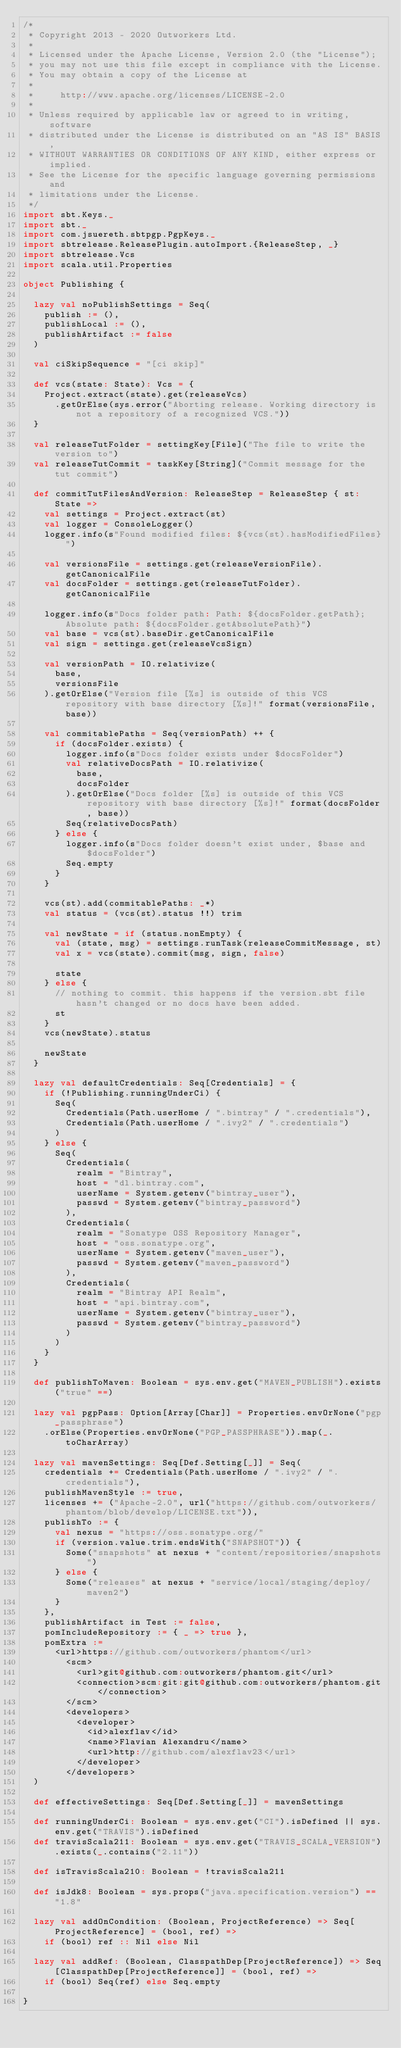<code> <loc_0><loc_0><loc_500><loc_500><_Scala_>/*
 * Copyright 2013 - 2020 Outworkers Ltd.
 *
 * Licensed under the Apache License, Version 2.0 (the "License");
 * you may not use this file except in compliance with the License.
 * You may obtain a copy of the License at
 *
 *     http://www.apache.org/licenses/LICENSE-2.0
 *
 * Unless required by applicable law or agreed to in writing, software
 * distributed under the License is distributed on an "AS IS" BASIS,
 * WITHOUT WARRANTIES OR CONDITIONS OF ANY KIND, either express or implied.
 * See the License for the specific language governing permissions and
 * limitations under the License.
 */
import sbt.Keys._
import sbt._
import com.jsuereth.sbtpgp.PgpKeys._
import sbtrelease.ReleasePlugin.autoImport.{ReleaseStep, _}
import sbtrelease.Vcs
import scala.util.Properties

object Publishing {

  lazy val noPublishSettings = Seq(
    publish := (),
    publishLocal := (),
    publishArtifact := false
  )

  val ciSkipSequence = "[ci skip]"

  def vcs(state: State): Vcs = {
    Project.extract(state).get(releaseVcs)
      .getOrElse(sys.error("Aborting release. Working directory is not a repository of a recognized VCS."))
  }

  val releaseTutFolder = settingKey[File]("The file to write the version to")
  val releaseTutCommit = taskKey[String]("Commit message for the tut commit")

  def commitTutFilesAndVersion: ReleaseStep = ReleaseStep { st: State =>
    val settings = Project.extract(st)
    val logger = ConsoleLogger()
    logger.info(s"Found modified files: ${vcs(st).hasModifiedFiles}")

    val versionsFile = settings.get(releaseVersionFile).getCanonicalFile
    val docsFolder = settings.get(releaseTutFolder).getCanonicalFile

    logger.info(s"Docs folder path: Path: ${docsFolder.getPath}; Absolute path: ${docsFolder.getAbsolutePath}")
    val base = vcs(st).baseDir.getCanonicalFile
    val sign = settings.get(releaseVcsSign)

    val versionPath = IO.relativize(
      base,
      versionsFile
    ).getOrElse("Version file [%s] is outside of this VCS repository with base directory [%s]!" format(versionsFile, base))

    val commitablePaths = Seq(versionPath) ++ {
      if (docsFolder.exists) {
        logger.info(s"Docs folder exists under $docsFolder")
        val relativeDocsPath = IO.relativize(
          base,
          docsFolder
        ).getOrElse("Docs folder [%s] is outside of this VCS repository with base directory [%s]!" format(docsFolder, base))
        Seq(relativeDocsPath)
      } else {
        logger.info(s"Docs folder doesn't exist under, $base and $docsFolder")
        Seq.empty
      }
    }

    vcs(st).add(commitablePaths: _*)
    val status = (vcs(st).status !!) trim

    val newState = if (status.nonEmpty) {
      val (state, msg) = settings.runTask(releaseCommitMessage, st)
      val x = vcs(state).commit(msg, sign, false)

      state
    } else {
      // nothing to commit. this happens if the version.sbt file hasn't changed or no docs have been added.
      st
    }
    vcs(newState).status

    newState
  }

  lazy val defaultCredentials: Seq[Credentials] = {
    if (!Publishing.runningUnderCi) {
      Seq(
        Credentials(Path.userHome / ".bintray" / ".credentials"),
        Credentials(Path.userHome / ".ivy2" / ".credentials")
      )
    } else {
      Seq(
        Credentials(
          realm = "Bintray",
          host = "dl.bintray.com",
          userName = System.getenv("bintray_user"),
          passwd = System.getenv("bintray_password")
        ),
        Credentials(
          realm = "Sonatype OSS Repository Manager",
          host = "oss.sonatype.org",
          userName = System.getenv("maven_user"),
          passwd = System.getenv("maven_password")
        ),
        Credentials(
          realm = "Bintray API Realm",
          host = "api.bintray.com",
          userName = System.getenv("bintray_user"),
          passwd = System.getenv("bintray_password")
        )
      )
    }
  }

  def publishToMaven: Boolean = sys.env.get("MAVEN_PUBLISH").exists("true" ==)

  lazy val pgpPass: Option[Array[Char]] = Properties.envOrNone("pgp_passphrase")
    .orElse(Properties.envOrNone("PGP_PASSPHRASE")).map(_.toCharArray)

  lazy val mavenSettings: Seq[Def.Setting[_]] = Seq(
    credentials += Credentials(Path.userHome / ".ivy2" / ".credentials"),
    publishMavenStyle := true,
    licenses += ("Apache-2.0", url("https://github.com/outworkers/phantom/blob/develop/LICENSE.txt")),
    publishTo := {
      val nexus = "https://oss.sonatype.org/"
      if (version.value.trim.endsWith("SNAPSHOT")) {
        Some("snapshots" at nexus + "content/repositories/snapshots")
      } else {
        Some("releases" at nexus + "service/local/staging/deploy/maven2")
      }
    },
    publishArtifact in Test := false,
    pomIncludeRepository := { _ => true },
    pomExtra :=
      <url>https://github.com/outworkers/phantom</url>
        <scm>
          <url>git@github.com:outworkers/phantom.git</url>
          <connection>scm:git:git@github.com:outworkers/phantom.git</connection>
        </scm>
        <developers>
          <developer>
            <id>alexflav</id>
            <name>Flavian Alexandru</name>
            <url>http://github.com/alexflav23</url>
          </developer>
        </developers>
  )

  def effectiveSettings: Seq[Def.Setting[_]] = mavenSettings

  def runningUnderCi: Boolean = sys.env.get("CI").isDefined || sys.env.get("TRAVIS").isDefined
  def travisScala211: Boolean = sys.env.get("TRAVIS_SCALA_VERSION").exists(_.contains("2.11"))

  def isTravisScala210: Boolean = !travisScala211

  def isJdk8: Boolean = sys.props("java.specification.version") == "1.8"

  lazy val addOnCondition: (Boolean, ProjectReference) => Seq[ProjectReference] = (bool, ref) =>
    if (bool) ref :: Nil else Nil

  lazy val addRef: (Boolean, ClasspathDep[ProjectReference]) => Seq[ClasspathDep[ProjectReference]] = (bool, ref) =>
    if (bool) Seq(ref) else Seq.empty

}
</code> 